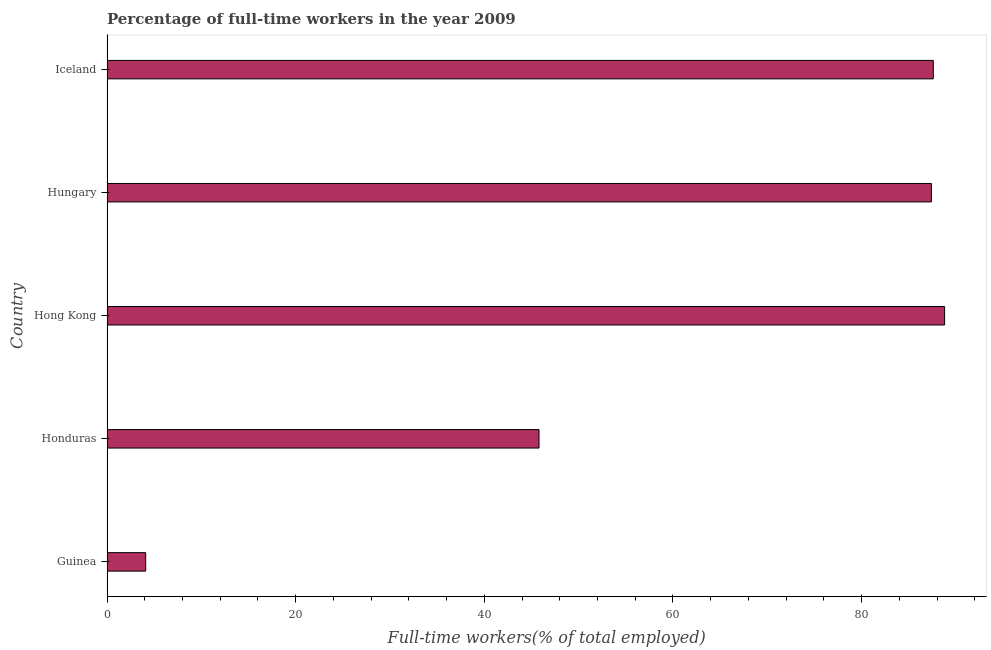What is the title of the graph?
Provide a succinct answer. Percentage of full-time workers in the year 2009. What is the label or title of the X-axis?
Provide a succinct answer. Full-time workers(% of total employed). What is the percentage of full-time workers in Honduras?
Your response must be concise. 45.8. Across all countries, what is the maximum percentage of full-time workers?
Provide a short and direct response. 88.8. Across all countries, what is the minimum percentage of full-time workers?
Your response must be concise. 4.1. In which country was the percentage of full-time workers maximum?
Offer a very short reply. Hong Kong. In which country was the percentage of full-time workers minimum?
Provide a succinct answer. Guinea. What is the sum of the percentage of full-time workers?
Give a very brief answer. 313.7. What is the difference between the percentage of full-time workers in Guinea and Hungary?
Offer a very short reply. -83.3. What is the average percentage of full-time workers per country?
Your response must be concise. 62.74. What is the median percentage of full-time workers?
Your answer should be very brief. 87.4. What is the ratio of the percentage of full-time workers in Hungary to that in Iceland?
Ensure brevity in your answer.  1. Is the percentage of full-time workers in Hong Kong less than that in Iceland?
Ensure brevity in your answer.  No. Is the difference between the percentage of full-time workers in Guinea and Hungary greater than the difference between any two countries?
Offer a terse response. No. What is the difference between the highest and the lowest percentage of full-time workers?
Your answer should be compact. 84.7. In how many countries, is the percentage of full-time workers greater than the average percentage of full-time workers taken over all countries?
Your response must be concise. 3. How many bars are there?
Ensure brevity in your answer.  5. How many countries are there in the graph?
Offer a terse response. 5. Are the values on the major ticks of X-axis written in scientific E-notation?
Ensure brevity in your answer.  No. What is the Full-time workers(% of total employed) of Guinea?
Offer a terse response. 4.1. What is the Full-time workers(% of total employed) in Honduras?
Give a very brief answer. 45.8. What is the Full-time workers(% of total employed) in Hong Kong?
Give a very brief answer. 88.8. What is the Full-time workers(% of total employed) in Hungary?
Make the answer very short. 87.4. What is the Full-time workers(% of total employed) of Iceland?
Keep it short and to the point. 87.6. What is the difference between the Full-time workers(% of total employed) in Guinea and Honduras?
Your response must be concise. -41.7. What is the difference between the Full-time workers(% of total employed) in Guinea and Hong Kong?
Provide a succinct answer. -84.7. What is the difference between the Full-time workers(% of total employed) in Guinea and Hungary?
Provide a succinct answer. -83.3. What is the difference between the Full-time workers(% of total employed) in Guinea and Iceland?
Provide a succinct answer. -83.5. What is the difference between the Full-time workers(% of total employed) in Honduras and Hong Kong?
Offer a terse response. -43. What is the difference between the Full-time workers(% of total employed) in Honduras and Hungary?
Ensure brevity in your answer.  -41.6. What is the difference between the Full-time workers(% of total employed) in Honduras and Iceland?
Your answer should be very brief. -41.8. What is the difference between the Full-time workers(% of total employed) in Hong Kong and Hungary?
Offer a terse response. 1.4. What is the difference between the Full-time workers(% of total employed) in Hong Kong and Iceland?
Give a very brief answer. 1.2. What is the ratio of the Full-time workers(% of total employed) in Guinea to that in Honduras?
Keep it short and to the point. 0.09. What is the ratio of the Full-time workers(% of total employed) in Guinea to that in Hong Kong?
Ensure brevity in your answer.  0.05. What is the ratio of the Full-time workers(% of total employed) in Guinea to that in Hungary?
Give a very brief answer. 0.05. What is the ratio of the Full-time workers(% of total employed) in Guinea to that in Iceland?
Keep it short and to the point. 0.05. What is the ratio of the Full-time workers(% of total employed) in Honduras to that in Hong Kong?
Your answer should be compact. 0.52. What is the ratio of the Full-time workers(% of total employed) in Honduras to that in Hungary?
Give a very brief answer. 0.52. What is the ratio of the Full-time workers(% of total employed) in Honduras to that in Iceland?
Keep it short and to the point. 0.52. What is the ratio of the Full-time workers(% of total employed) in Hong Kong to that in Hungary?
Provide a short and direct response. 1.02. What is the ratio of the Full-time workers(% of total employed) in Hong Kong to that in Iceland?
Your answer should be compact. 1.01. What is the ratio of the Full-time workers(% of total employed) in Hungary to that in Iceland?
Your answer should be very brief. 1. 